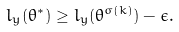<formula> <loc_0><loc_0><loc_500><loc_500>l _ { y } ( \theta ^ { * } ) \geq l _ { y } ( \theta ^ { \sigma ( k ) } ) - \epsilon .</formula> 